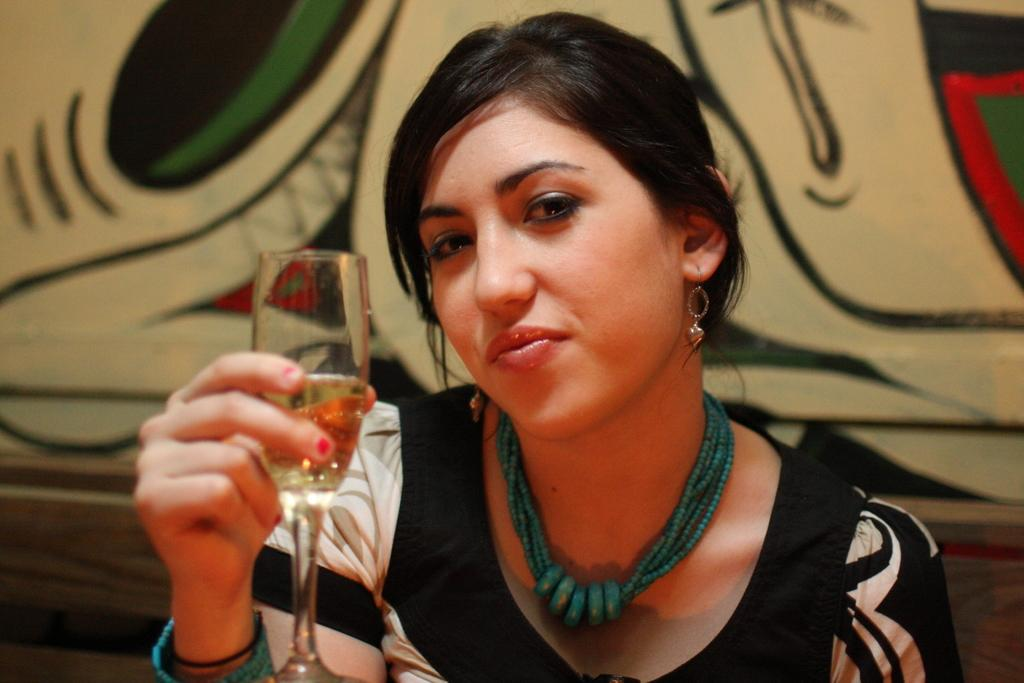Who is the main subject in the image? There is a lady in the image. What is the lady wearing? The lady is wearing a black dress. What is the lady doing in the image? The lady is sitting. What is the lady holding in her hand? She is holding a glass in her hand. What type of accessory is the lady wearing around her neck? There is a chain around her neck. What type of cushion is the lady sitting on in the image? The provided facts do not mention a cushion, so we cannot determine the type of cushion the lady is sitting on. 